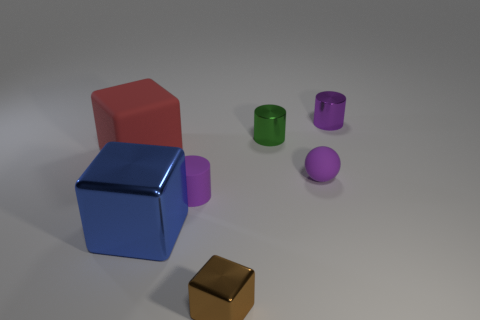The small block is what color?
Keep it short and to the point. Brown. Are there any tiny matte objects of the same color as the tiny matte cylinder?
Make the answer very short. Yes. There is a small purple object that is on the left side of the rubber thing right of the purple cylinder that is in front of the large red rubber cube; what is its shape?
Your answer should be very brief. Cylinder. What is the material of the tiny purple cylinder right of the green object?
Ensure brevity in your answer.  Metal. There is a blue metallic thing that is in front of the tiny shiny cylinder that is in front of the shiny cylinder behind the green thing; what size is it?
Ensure brevity in your answer.  Large. There is a purple matte cylinder; does it have the same size as the blue shiny cube in front of the red matte thing?
Your response must be concise. No. The matte sphere in front of the large matte thing is what color?
Your answer should be very brief. Purple. There is a metallic thing that is the same color as the rubber cylinder; what is its shape?
Your response must be concise. Cylinder. What shape is the blue object that is left of the green object?
Offer a terse response. Cube. How many gray objects are rubber balls or big matte objects?
Your response must be concise. 0. 